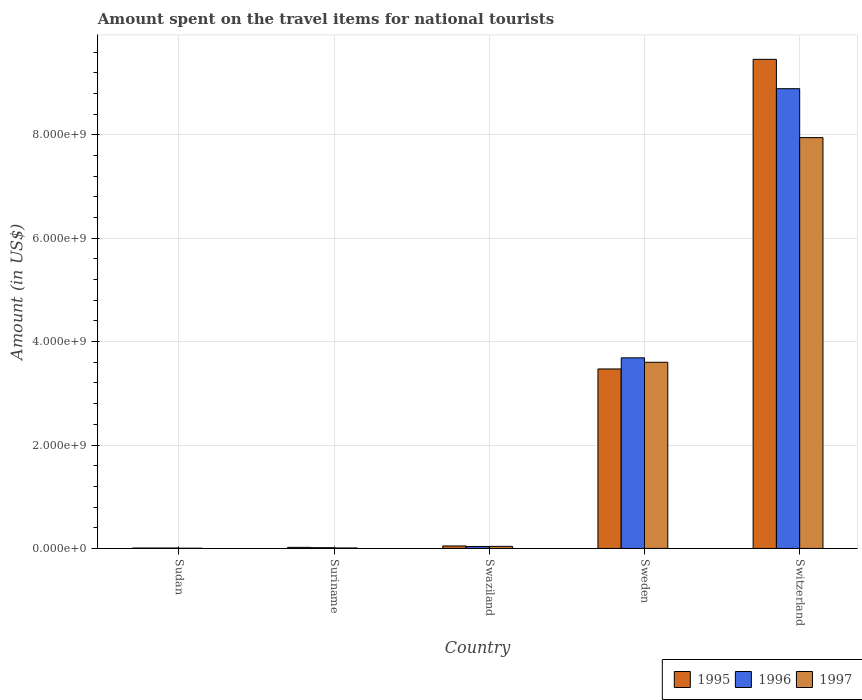How many groups of bars are there?
Offer a very short reply. 5. Are the number of bars on each tick of the X-axis equal?
Your answer should be compact. Yes. How many bars are there on the 4th tick from the left?
Offer a terse response. 3. How many bars are there on the 1st tick from the right?
Offer a very short reply. 3. What is the label of the 2nd group of bars from the left?
Ensure brevity in your answer.  Suriname. In how many cases, is the number of bars for a given country not equal to the number of legend labels?
Your answer should be very brief. 0. What is the amount spent on the travel items for national tourists in 1996 in Sudan?
Your answer should be compact. 8.00e+06. Across all countries, what is the maximum amount spent on the travel items for national tourists in 1996?
Offer a terse response. 8.89e+09. Across all countries, what is the minimum amount spent on the travel items for national tourists in 1995?
Provide a short and direct response. 8.00e+06. In which country was the amount spent on the travel items for national tourists in 1996 maximum?
Provide a short and direct response. Switzerland. In which country was the amount spent on the travel items for national tourists in 1995 minimum?
Make the answer very short. Sudan. What is the total amount spent on the travel items for national tourists in 1995 in the graph?
Make the answer very short. 1.30e+1. What is the difference between the amount spent on the travel items for national tourists in 1997 in Sudan and that in Swaziland?
Your response must be concise. -3.60e+07. What is the difference between the amount spent on the travel items for national tourists in 1995 in Switzerland and the amount spent on the travel items for national tourists in 1997 in Sudan?
Keep it short and to the point. 9.46e+09. What is the average amount spent on the travel items for national tourists in 1997 per country?
Your answer should be very brief. 2.32e+09. In how many countries, is the amount spent on the travel items for national tourists in 1997 greater than 5200000000 US$?
Offer a very short reply. 1. What is the ratio of the amount spent on the travel items for national tourists in 1996 in Swaziland to that in Switzerland?
Keep it short and to the point. 0. Is the difference between the amount spent on the travel items for national tourists in 1995 in Suriname and Switzerland greater than the difference between the amount spent on the travel items for national tourists in 1997 in Suriname and Switzerland?
Offer a terse response. No. What is the difference between the highest and the second highest amount spent on the travel items for national tourists in 1995?
Your answer should be compact. 9.41e+09. What is the difference between the highest and the lowest amount spent on the travel items for national tourists in 1997?
Ensure brevity in your answer.  7.94e+09. What does the 2nd bar from the left in Sweden represents?
Keep it short and to the point. 1996. Are all the bars in the graph horizontal?
Give a very brief answer. No. What is the difference between two consecutive major ticks on the Y-axis?
Provide a short and direct response. 2.00e+09. What is the title of the graph?
Your answer should be compact. Amount spent on the travel items for national tourists. What is the label or title of the Y-axis?
Give a very brief answer. Amount (in US$). What is the Amount (in US$) in 1995 in Sudan?
Ensure brevity in your answer.  8.00e+06. What is the Amount (in US$) in 1996 in Sudan?
Provide a short and direct response. 8.00e+06. What is the Amount (in US$) in 1997 in Sudan?
Give a very brief answer. 4.00e+06. What is the Amount (in US$) in 1995 in Suriname?
Provide a succinct answer. 2.10e+07. What is the Amount (in US$) in 1996 in Suriname?
Keep it short and to the point. 1.40e+07. What is the Amount (in US$) in 1997 in Suriname?
Make the answer very short. 9.00e+06. What is the Amount (in US$) in 1995 in Swaziland?
Ensure brevity in your answer.  4.80e+07. What is the Amount (in US$) in 1996 in Swaziland?
Ensure brevity in your answer.  3.80e+07. What is the Amount (in US$) in 1997 in Swaziland?
Your answer should be compact. 4.00e+07. What is the Amount (in US$) of 1995 in Sweden?
Keep it short and to the point. 3.47e+09. What is the Amount (in US$) of 1996 in Sweden?
Your answer should be compact. 3.69e+09. What is the Amount (in US$) in 1997 in Sweden?
Offer a very short reply. 3.60e+09. What is the Amount (in US$) in 1995 in Switzerland?
Your answer should be compact. 9.46e+09. What is the Amount (in US$) in 1996 in Switzerland?
Make the answer very short. 8.89e+09. What is the Amount (in US$) of 1997 in Switzerland?
Give a very brief answer. 7.94e+09. Across all countries, what is the maximum Amount (in US$) in 1995?
Offer a terse response. 9.46e+09. Across all countries, what is the maximum Amount (in US$) in 1996?
Offer a very short reply. 8.89e+09. Across all countries, what is the maximum Amount (in US$) of 1997?
Offer a terse response. 7.94e+09. Across all countries, what is the minimum Amount (in US$) in 1996?
Offer a terse response. 8.00e+06. What is the total Amount (in US$) of 1995 in the graph?
Your response must be concise. 1.30e+1. What is the total Amount (in US$) of 1996 in the graph?
Make the answer very short. 1.26e+1. What is the total Amount (in US$) of 1997 in the graph?
Ensure brevity in your answer.  1.16e+1. What is the difference between the Amount (in US$) in 1995 in Sudan and that in Suriname?
Provide a short and direct response. -1.30e+07. What is the difference between the Amount (in US$) of 1996 in Sudan and that in Suriname?
Provide a short and direct response. -6.00e+06. What is the difference between the Amount (in US$) in 1997 in Sudan and that in Suriname?
Offer a very short reply. -5.00e+06. What is the difference between the Amount (in US$) of 1995 in Sudan and that in Swaziland?
Provide a short and direct response. -4.00e+07. What is the difference between the Amount (in US$) of 1996 in Sudan and that in Swaziland?
Make the answer very short. -3.00e+07. What is the difference between the Amount (in US$) of 1997 in Sudan and that in Swaziland?
Your response must be concise. -3.60e+07. What is the difference between the Amount (in US$) in 1995 in Sudan and that in Sweden?
Make the answer very short. -3.46e+09. What is the difference between the Amount (in US$) of 1996 in Sudan and that in Sweden?
Keep it short and to the point. -3.68e+09. What is the difference between the Amount (in US$) of 1997 in Sudan and that in Sweden?
Ensure brevity in your answer.  -3.60e+09. What is the difference between the Amount (in US$) of 1995 in Sudan and that in Switzerland?
Keep it short and to the point. -9.45e+09. What is the difference between the Amount (in US$) in 1996 in Sudan and that in Switzerland?
Make the answer very short. -8.88e+09. What is the difference between the Amount (in US$) of 1997 in Sudan and that in Switzerland?
Ensure brevity in your answer.  -7.94e+09. What is the difference between the Amount (in US$) in 1995 in Suriname and that in Swaziland?
Offer a terse response. -2.70e+07. What is the difference between the Amount (in US$) in 1996 in Suriname and that in Swaziland?
Ensure brevity in your answer.  -2.40e+07. What is the difference between the Amount (in US$) of 1997 in Suriname and that in Swaziland?
Ensure brevity in your answer.  -3.10e+07. What is the difference between the Amount (in US$) in 1995 in Suriname and that in Sweden?
Keep it short and to the point. -3.45e+09. What is the difference between the Amount (in US$) in 1996 in Suriname and that in Sweden?
Your answer should be very brief. -3.67e+09. What is the difference between the Amount (in US$) of 1997 in Suriname and that in Sweden?
Offer a very short reply. -3.59e+09. What is the difference between the Amount (in US$) of 1995 in Suriname and that in Switzerland?
Your answer should be compact. -9.44e+09. What is the difference between the Amount (in US$) of 1996 in Suriname and that in Switzerland?
Your answer should be compact. -8.88e+09. What is the difference between the Amount (in US$) in 1997 in Suriname and that in Switzerland?
Your answer should be very brief. -7.94e+09. What is the difference between the Amount (in US$) in 1995 in Swaziland and that in Sweden?
Offer a very short reply. -3.42e+09. What is the difference between the Amount (in US$) of 1996 in Swaziland and that in Sweden?
Make the answer very short. -3.65e+09. What is the difference between the Amount (in US$) of 1997 in Swaziland and that in Sweden?
Offer a very short reply. -3.56e+09. What is the difference between the Amount (in US$) of 1995 in Swaziland and that in Switzerland?
Provide a succinct answer. -9.41e+09. What is the difference between the Amount (in US$) in 1996 in Swaziland and that in Switzerland?
Offer a terse response. -8.85e+09. What is the difference between the Amount (in US$) in 1997 in Swaziland and that in Switzerland?
Provide a succinct answer. -7.90e+09. What is the difference between the Amount (in US$) in 1995 in Sweden and that in Switzerland?
Offer a terse response. -5.99e+09. What is the difference between the Amount (in US$) of 1996 in Sweden and that in Switzerland?
Ensure brevity in your answer.  -5.20e+09. What is the difference between the Amount (in US$) of 1997 in Sweden and that in Switzerland?
Your answer should be compact. -4.34e+09. What is the difference between the Amount (in US$) of 1995 in Sudan and the Amount (in US$) of 1996 in Suriname?
Offer a terse response. -6.00e+06. What is the difference between the Amount (in US$) of 1995 in Sudan and the Amount (in US$) of 1997 in Suriname?
Your answer should be compact. -1.00e+06. What is the difference between the Amount (in US$) of 1995 in Sudan and the Amount (in US$) of 1996 in Swaziland?
Your response must be concise. -3.00e+07. What is the difference between the Amount (in US$) of 1995 in Sudan and the Amount (in US$) of 1997 in Swaziland?
Your response must be concise. -3.20e+07. What is the difference between the Amount (in US$) in 1996 in Sudan and the Amount (in US$) in 1997 in Swaziland?
Your answer should be very brief. -3.20e+07. What is the difference between the Amount (in US$) in 1995 in Sudan and the Amount (in US$) in 1996 in Sweden?
Offer a terse response. -3.68e+09. What is the difference between the Amount (in US$) in 1995 in Sudan and the Amount (in US$) in 1997 in Sweden?
Offer a terse response. -3.59e+09. What is the difference between the Amount (in US$) of 1996 in Sudan and the Amount (in US$) of 1997 in Sweden?
Your answer should be compact. -3.59e+09. What is the difference between the Amount (in US$) of 1995 in Sudan and the Amount (in US$) of 1996 in Switzerland?
Offer a terse response. -8.88e+09. What is the difference between the Amount (in US$) of 1995 in Sudan and the Amount (in US$) of 1997 in Switzerland?
Offer a very short reply. -7.94e+09. What is the difference between the Amount (in US$) in 1996 in Sudan and the Amount (in US$) in 1997 in Switzerland?
Offer a very short reply. -7.94e+09. What is the difference between the Amount (in US$) of 1995 in Suriname and the Amount (in US$) of 1996 in Swaziland?
Offer a very short reply. -1.70e+07. What is the difference between the Amount (in US$) of 1995 in Suriname and the Amount (in US$) of 1997 in Swaziland?
Ensure brevity in your answer.  -1.90e+07. What is the difference between the Amount (in US$) of 1996 in Suriname and the Amount (in US$) of 1997 in Swaziland?
Offer a terse response. -2.60e+07. What is the difference between the Amount (in US$) in 1995 in Suriname and the Amount (in US$) in 1996 in Sweden?
Keep it short and to the point. -3.66e+09. What is the difference between the Amount (in US$) in 1995 in Suriname and the Amount (in US$) in 1997 in Sweden?
Your response must be concise. -3.58e+09. What is the difference between the Amount (in US$) of 1996 in Suriname and the Amount (in US$) of 1997 in Sweden?
Offer a terse response. -3.59e+09. What is the difference between the Amount (in US$) of 1995 in Suriname and the Amount (in US$) of 1996 in Switzerland?
Your answer should be compact. -8.87e+09. What is the difference between the Amount (in US$) of 1995 in Suriname and the Amount (in US$) of 1997 in Switzerland?
Your response must be concise. -7.92e+09. What is the difference between the Amount (in US$) in 1996 in Suriname and the Amount (in US$) in 1997 in Switzerland?
Provide a succinct answer. -7.93e+09. What is the difference between the Amount (in US$) of 1995 in Swaziland and the Amount (in US$) of 1996 in Sweden?
Offer a very short reply. -3.64e+09. What is the difference between the Amount (in US$) of 1995 in Swaziland and the Amount (in US$) of 1997 in Sweden?
Your answer should be very brief. -3.55e+09. What is the difference between the Amount (in US$) of 1996 in Swaziland and the Amount (in US$) of 1997 in Sweden?
Provide a short and direct response. -3.56e+09. What is the difference between the Amount (in US$) in 1995 in Swaziland and the Amount (in US$) in 1996 in Switzerland?
Offer a very short reply. -8.84e+09. What is the difference between the Amount (in US$) in 1995 in Swaziland and the Amount (in US$) in 1997 in Switzerland?
Make the answer very short. -7.90e+09. What is the difference between the Amount (in US$) of 1996 in Swaziland and the Amount (in US$) of 1997 in Switzerland?
Offer a very short reply. -7.91e+09. What is the difference between the Amount (in US$) of 1995 in Sweden and the Amount (in US$) of 1996 in Switzerland?
Your answer should be very brief. -5.42e+09. What is the difference between the Amount (in US$) in 1995 in Sweden and the Amount (in US$) in 1997 in Switzerland?
Provide a short and direct response. -4.47e+09. What is the difference between the Amount (in US$) in 1996 in Sweden and the Amount (in US$) in 1997 in Switzerland?
Keep it short and to the point. -4.26e+09. What is the average Amount (in US$) of 1995 per country?
Give a very brief answer. 2.60e+09. What is the average Amount (in US$) in 1996 per country?
Provide a short and direct response. 2.53e+09. What is the average Amount (in US$) of 1997 per country?
Ensure brevity in your answer.  2.32e+09. What is the difference between the Amount (in US$) of 1996 and Amount (in US$) of 1997 in Suriname?
Provide a short and direct response. 5.00e+06. What is the difference between the Amount (in US$) in 1995 and Amount (in US$) in 1996 in Swaziland?
Give a very brief answer. 1.00e+07. What is the difference between the Amount (in US$) in 1995 and Amount (in US$) in 1997 in Swaziland?
Offer a terse response. 8.00e+06. What is the difference between the Amount (in US$) in 1996 and Amount (in US$) in 1997 in Swaziland?
Offer a terse response. -2.00e+06. What is the difference between the Amount (in US$) in 1995 and Amount (in US$) in 1996 in Sweden?
Give a very brief answer. -2.15e+08. What is the difference between the Amount (in US$) in 1995 and Amount (in US$) in 1997 in Sweden?
Ensure brevity in your answer.  -1.29e+08. What is the difference between the Amount (in US$) in 1996 and Amount (in US$) in 1997 in Sweden?
Provide a short and direct response. 8.60e+07. What is the difference between the Amount (in US$) of 1995 and Amount (in US$) of 1996 in Switzerland?
Ensure brevity in your answer.  5.68e+08. What is the difference between the Amount (in US$) in 1995 and Amount (in US$) in 1997 in Switzerland?
Give a very brief answer. 1.51e+09. What is the difference between the Amount (in US$) in 1996 and Amount (in US$) in 1997 in Switzerland?
Make the answer very short. 9.46e+08. What is the ratio of the Amount (in US$) of 1995 in Sudan to that in Suriname?
Provide a succinct answer. 0.38. What is the ratio of the Amount (in US$) of 1997 in Sudan to that in Suriname?
Your answer should be very brief. 0.44. What is the ratio of the Amount (in US$) in 1995 in Sudan to that in Swaziland?
Make the answer very short. 0.17. What is the ratio of the Amount (in US$) in 1996 in Sudan to that in Swaziland?
Keep it short and to the point. 0.21. What is the ratio of the Amount (in US$) of 1997 in Sudan to that in Swaziland?
Provide a short and direct response. 0.1. What is the ratio of the Amount (in US$) in 1995 in Sudan to that in Sweden?
Provide a short and direct response. 0. What is the ratio of the Amount (in US$) in 1996 in Sudan to that in Sweden?
Provide a succinct answer. 0. What is the ratio of the Amount (in US$) in 1997 in Sudan to that in Sweden?
Ensure brevity in your answer.  0. What is the ratio of the Amount (in US$) in 1995 in Sudan to that in Switzerland?
Make the answer very short. 0. What is the ratio of the Amount (in US$) in 1996 in Sudan to that in Switzerland?
Keep it short and to the point. 0. What is the ratio of the Amount (in US$) of 1995 in Suriname to that in Swaziland?
Offer a very short reply. 0.44. What is the ratio of the Amount (in US$) in 1996 in Suriname to that in Swaziland?
Give a very brief answer. 0.37. What is the ratio of the Amount (in US$) of 1997 in Suriname to that in Swaziland?
Make the answer very short. 0.23. What is the ratio of the Amount (in US$) of 1995 in Suriname to that in Sweden?
Provide a succinct answer. 0.01. What is the ratio of the Amount (in US$) of 1996 in Suriname to that in Sweden?
Provide a short and direct response. 0. What is the ratio of the Amount (in US$) of 1997 in Suriname to that in Sweden?
Your answer should be very brief. 0. What is the ratio of the Amount (in US$) of 1995 in Suriname to that in Switzerland?
Your answer should be very brief. 0. What is the ratio of the Amount (in US$) in 1996 in Suriname to that in Switzerland?
Ensure brevity in your answer.  0. What is the ratio of the Amount (in US$) in 1997 in Suriname to that in Switzerland?
Ensure brevity in your answer.  0. What is the ratio of the Amount (in US$) of 1995 in Swaziland to that in Sweden?
Provide a succinct answer. 0.01. What is the ratio of the Amount (in US$) of 1996 in Swaziland to that in Sweden?
Offer a very short reply. 0.01. What is the ratio of the Amount (in US$) in 1997 in Swaziland to that in Sweden?
Provide a succinct answer. 0.01. What is the ratio of the Amount (in US$) in 1995 in Swaziland to that in Switzerland?
Keep it short and to the point. 0.01. What is the ratio of the Amount (in US$) in 1996 in Swaziland to that in Switzerland?
Your answer should be compact. 0. What is the ratio of the Amount (in US$) in 1997 in Swaziland to that in Switzerland?
Your answer should be very brief. 0.01. What is the ratio of the Amount (in US$) of 1995 in Sweden to that in Switzerland?
Keep it short and to the point. 0.37. What is the ratio of the Amount (in US$) in 1996 in Sweden to that in Switzerland?
Make the answer very short. 0.41. What is the ratio of the Amount (in US$) of 1997 in Sweden to that in Switzerland?
Your answer should be compact. 0.45. What is the difference between the highest and the second highest Amount (in US$) in 1995?
Provide a short and direct response. 5.99e+09. What is the difference between the highest and the second highest Amount (in US$) of 1996?
Provide a succinct answer. 5.20e+09. What is the difference between the highest and the second highest Amount (in US$) in 1997?
Ensure brevity in your answer.  4.34e+09. What is the difference between the highest and the lowest Amount (in US$) in 1995?
Provide a short and direct response. 9.45e+09. What is the difference between the highest and the lowest Amount (in US$) of 1996?
Offer a very short reply. 8.88e+09. What is the difference between the highest and the lowest Amount (in US$) in 1997?
Ensure brevity in your answer.  7.94e+09. 